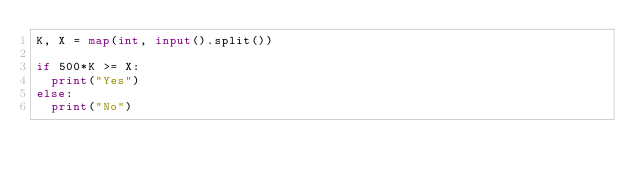<code> <loc_0><loc_0><loc_500><loc_500><_Python_>K, X = map(int, input().split())

if 500*K >= X:
  print("Yes")
else:
  print("No")</code> 